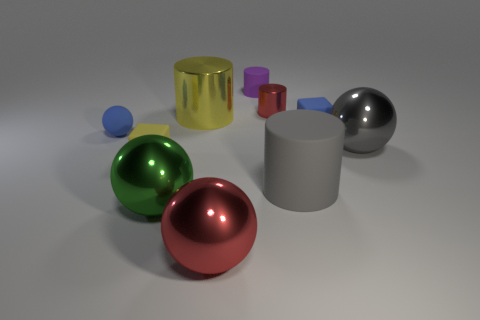Are there any other gray matte things of the same shape as the gray matte thing?
Make the answer very short. No. What number of tiny purple matte cubes are there?
Provide a succinct answer. 0. The yellow metallic thing is what shape?
Keep it short and to the point. Cylinder. What number of yellow cylinders are the same size as the purple thing?
Offer a terse response. 0. Does the tiny red metal object have the same shape as the yellow metal object?
Provide a succinct answer. Yes. There is a matte block that is on the left side of the big red metallic thing in front of the green metallic ball; what is its color?
Provide a short and direct response. Yellow. There is a sphere that is behind the big gray matte cylinder and left of the blue rubber block; how big is it?
Ensure brevity in your answer.  Small. Is there anything else of the same color as the small metal cylinder?
Your response must be concise. Yes. There is a large green thing that is the same material as the gray sphere; what shape is it?
Your answer should be compact. Sphere. Is the shape of the big green object the same as the big metal object that is behind the small rubber sphere?
Make the answer very short. No. 